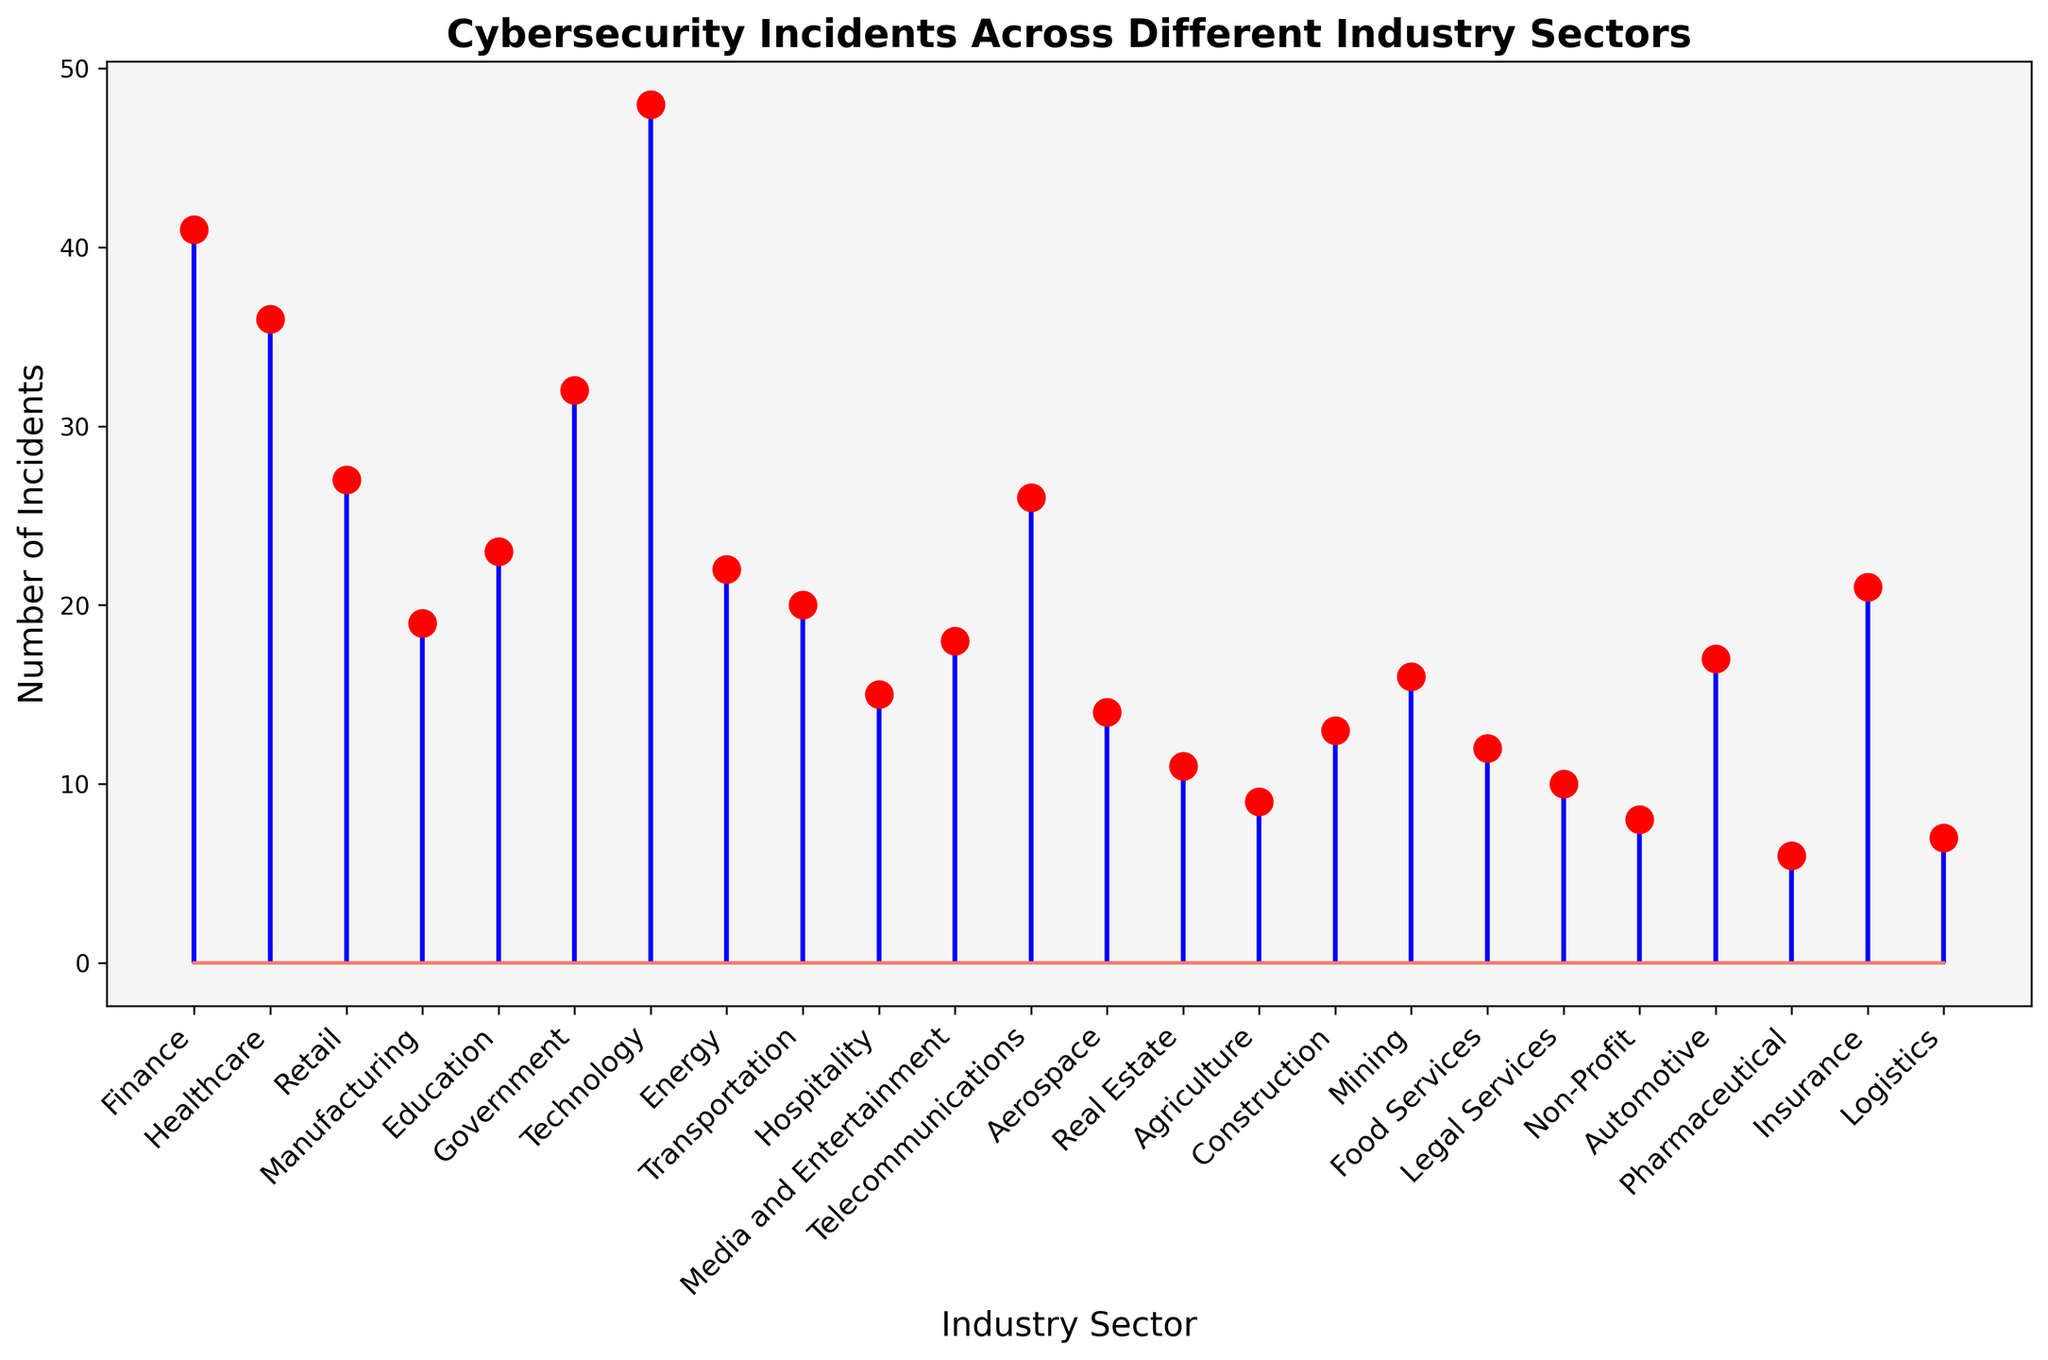Which industry sector has the highest number of cybersecurity incidents? The highest marker on the figure corresponds to the Technology sector.
Answer: Technology What is the difference in cybersecurity incidents between the Technology and Agriculture sectors? The number of incidents in Technology is 48 and in Agriculture is 9. The difference is 48 - 9 = 39.
Answer: 39 What is the sum of cybersecurity incidents in the Healthcare and Government sectors? The number of incidents in Healthcare is 36 and in Government is 32. The sum is 36 + 32 = 68.
Answer: 68 Is the number of cybersecurity incidents in the Finance sector higher than in the Healthcare sector? The Finance sector has 41 incidents while the Healthcare sector has 36 incidents. Since 41 > 36, the Finance sector has more incidents.
Answer: Yes What is the average number of cybersecurity incidents across the Education, Energy, and Transportation sectors? The number of incidents in Education, Energy, and Transportation are 23, 22, and 20 respectively. The sum is 23 + 22 + 20 = 65 and the average is 65/3 ≈ 21.67.
Answer: ≈ 21.67 Which sectors have fewer than 10 cybersecurity incidents? Agriculture (9), Non-Profit (8), Pharmaceutical (6), and Logistics (7) sectors each have fewer than 10 incidents.
Answer: Agriculture, Non-Profit, Pharmaceutical, Logistics How many more incidents does the Finance sector have compared to the Hospitality sector? The Finance sector has 41 incidents and the Hospitality sector has 15 incidents. The difference is 41 - 15 = 26.
Answer: 26 Which sector has exactly 16 cybersecurity incidents? The Mining sector has exactly 16 cybersecurity incidents.
Answer: Mining Are there more cybersecurity incidents in the Telecommunications sector compared to the Retail sector? The Telecommunications sector has 26 incidents while the Retail sector has 27 incidents. Since 26 < 27, the Telecommunications sector has fewer incidents.
Answer: No What is the median number of cybersecurity incidents in all sectors? The sorted list of incidents is [6, 7, 8, 9, 10, 11, 12, 13, 14, 15, 16, 17, 18, 19, 20, 21, 22, 23, 26, 27, 32, 36, 41, 48]. The median is the middle value, which is the average of the 12th and 13th values: (16 + 17)/2 = 16.5.
Answer: 16.5 